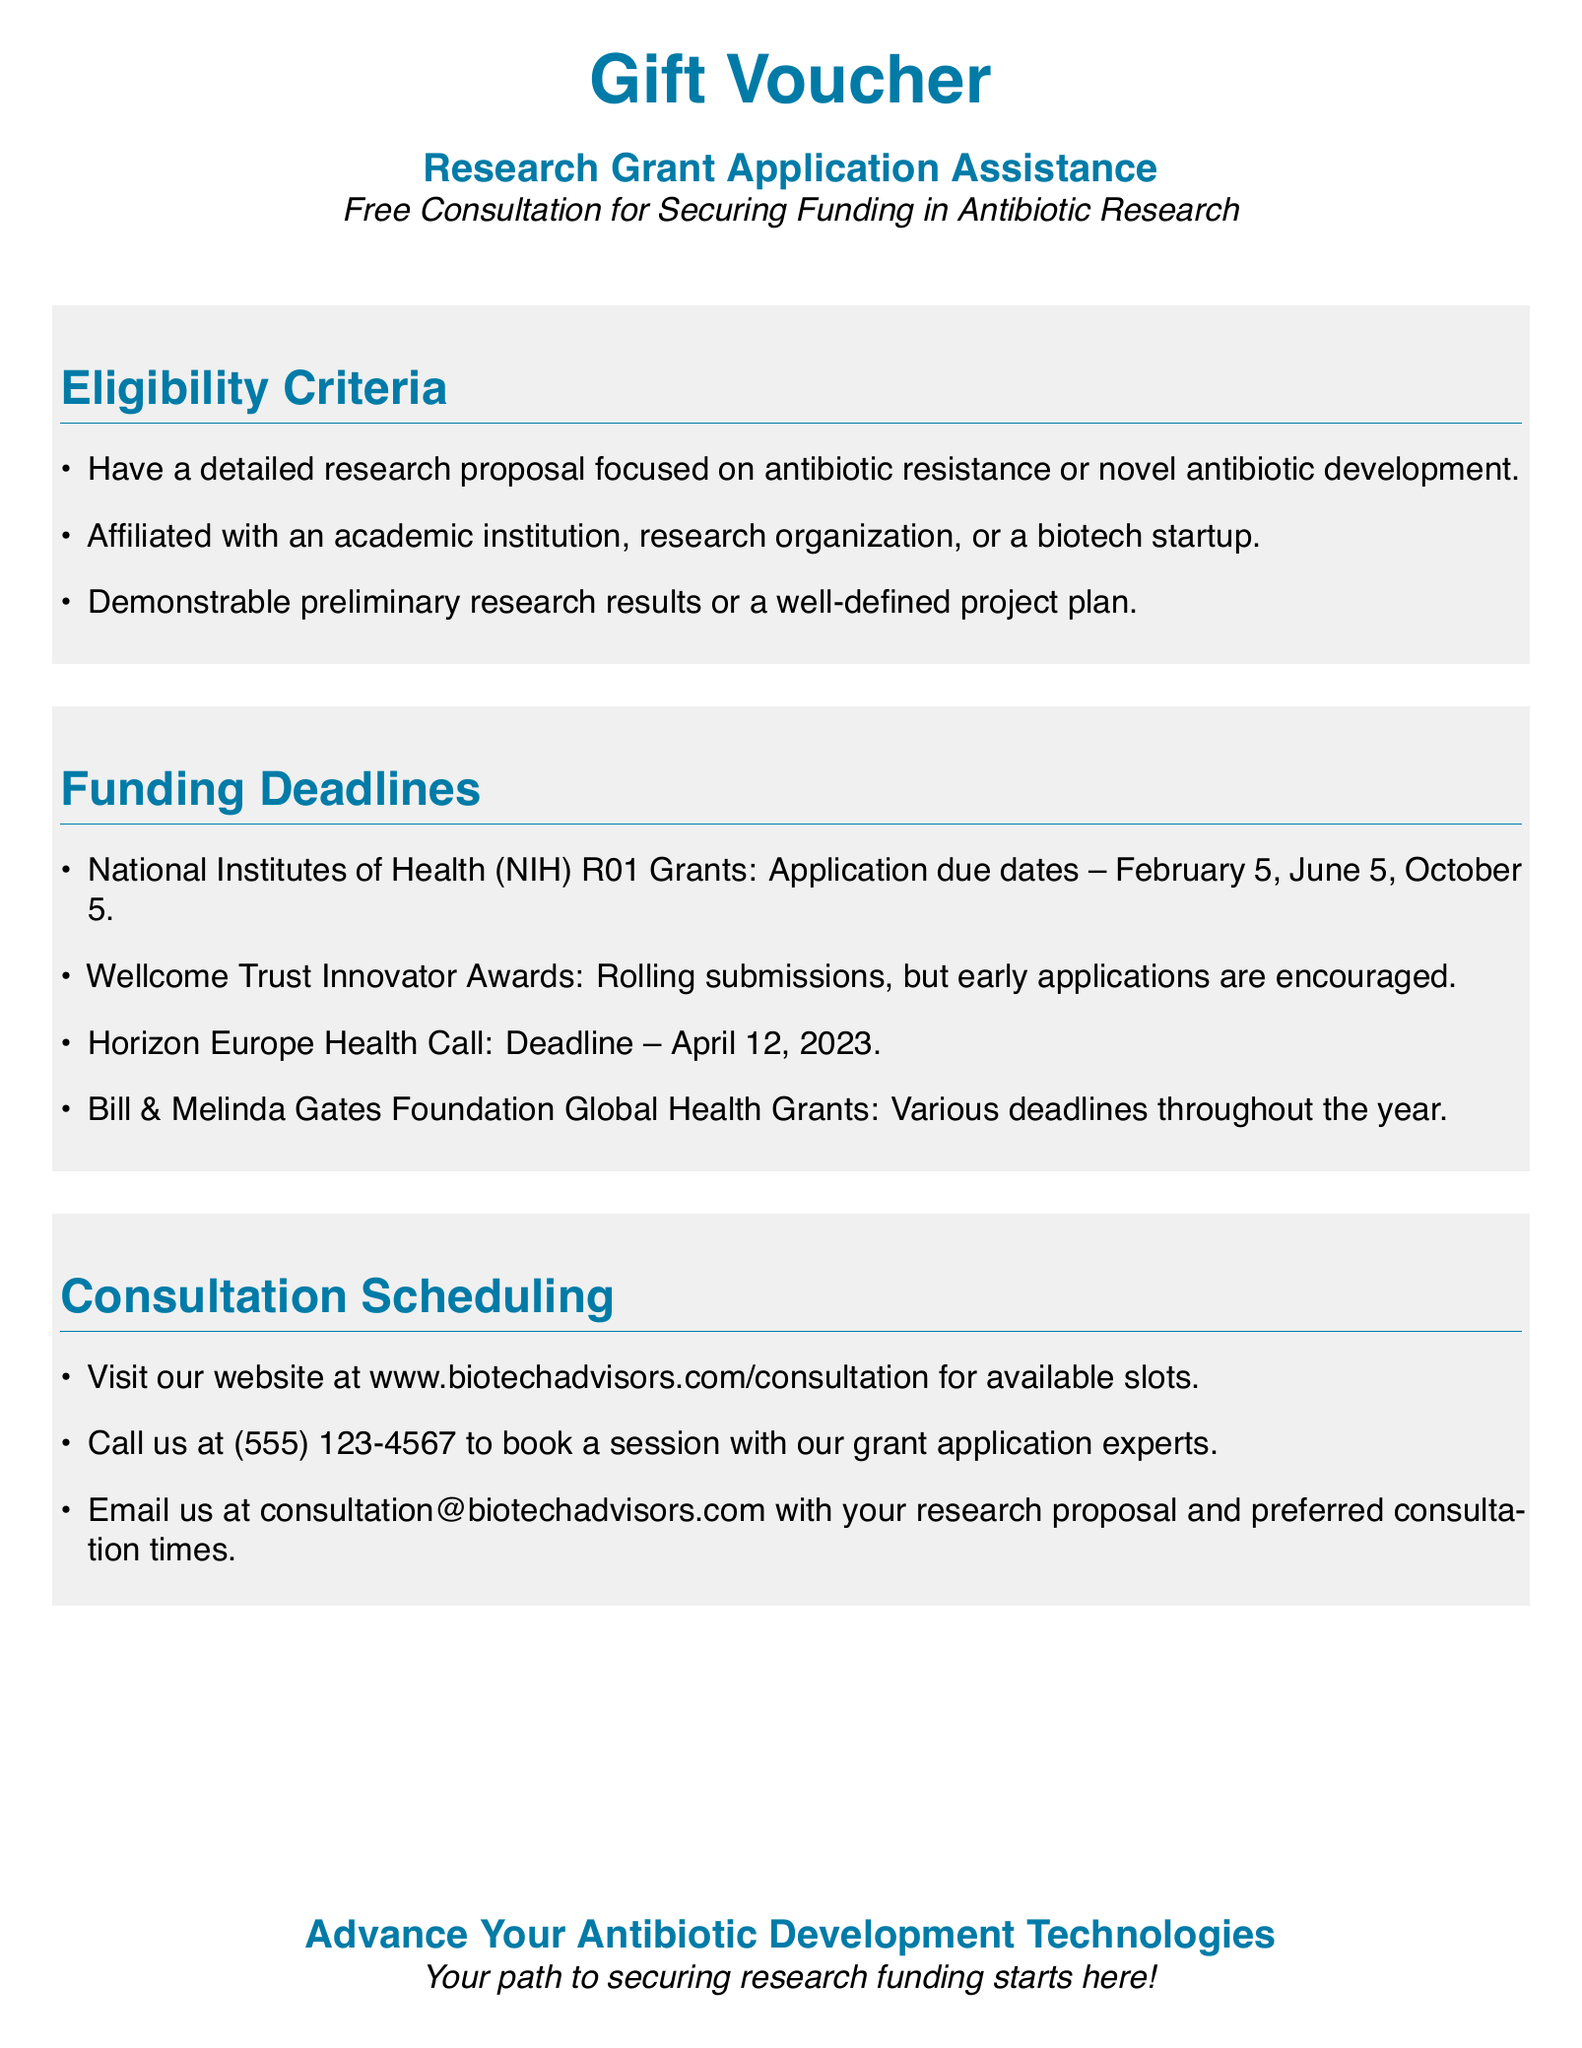What is the grant assistance focused on? The document specifies that the grant application assistance is for securing funding in antibiotic research.
Answer: Antibiotic research What type of research proposal is needed? The eligibility criteria mention that a detailed research proposal focused on antibiotic resistance or novel antibiotic development is required.
Answer: Antibiotic resistance or novel antibiotic development When is the application due for NIH R01 Grants? The funding deadlines section lists the application due dates for NIH R01 Grants, including February 5, June 5, and October 5.
Answer: February 5, June 5, October 5 How can you schedule a consultation? The document provides multiple options for scheduling a consultation, such as visiting a website, calling a phone number, or emailing.
Answer: Visit website, call, or email What is the deadline for the Horizon Europe Health Call? The funding deadlines section states that the deadline for the Horizon Europe Health Call is April 12, 2023.
Answer: April 12, 2023 Is early application encouraged for Wellcome Trust Innovator Awards? The funding deadlines section indicates that rolling submissions are available, but early applications are encouraged.
Answer: Yes Which organization offers Global Health Grants? The funding deadlines mention the Bill & Melinda Gates Foundation as the organization that offers Global Health Grants.
Answer: Bill & Melinda Gates Foundation What should you include in your email for consultation? The document specifies that you should include your research proposal and preferred consultation times in your email.
Answer: Research proposal and preferred consultation times What is the website for scheduling consultations? The document provides the URL for scheduling consultations at www.biotechadvisors.com/consultation.
Answer: www.biotechadvisors.com/consultation 